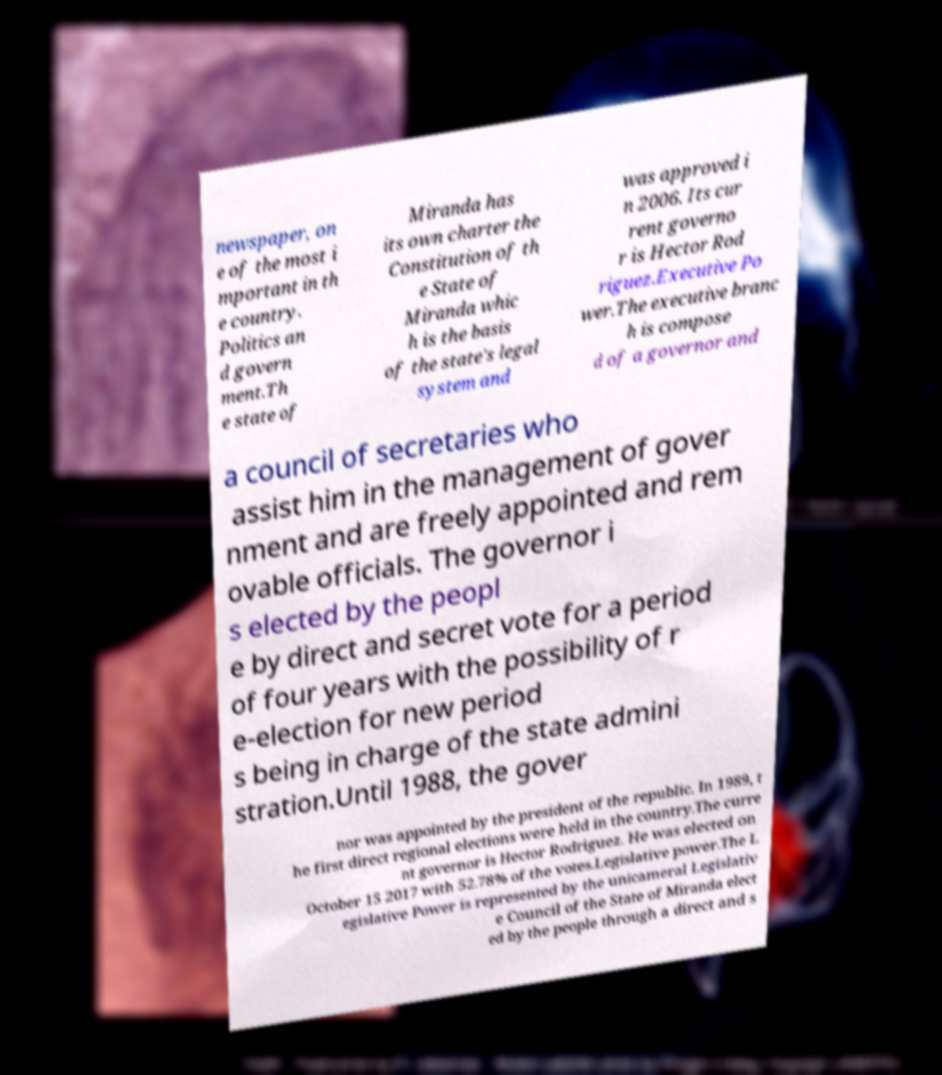Could you extract and type out the text from this image? newspaper, on e of the most i mportant in th e country. Politics an d govern ment.Th e state of Miranda has its own charter the Constitution of th e State of Miranda whic h is the basis of the state's legal system and was approved i n 2006. Its cur rent governo r is Hector Rod riguez.Executive Po wer.The executive branc h is compose d of a governor and a council of secretaries who assist him in the management of gover nment and are freely appointed and rem ovable officials. The governor i s elected by the peopl e by direct and secret vote for a period of four years with the possibility of r e-election for new period s being in charge of the state admini stration.Until 1988, the gover nor was appointed by the president of the republic. In 1989, t he first direct regional elections were held in the country.The curre nt governor is Hector Rodriguez. He was elected on October 15 2017 with 52.78% of the votes.Legislative power.The L egislative Power is represented by the unicameral Legislativ e Council of the State of Miranda elect ed by the people through a direct and s 